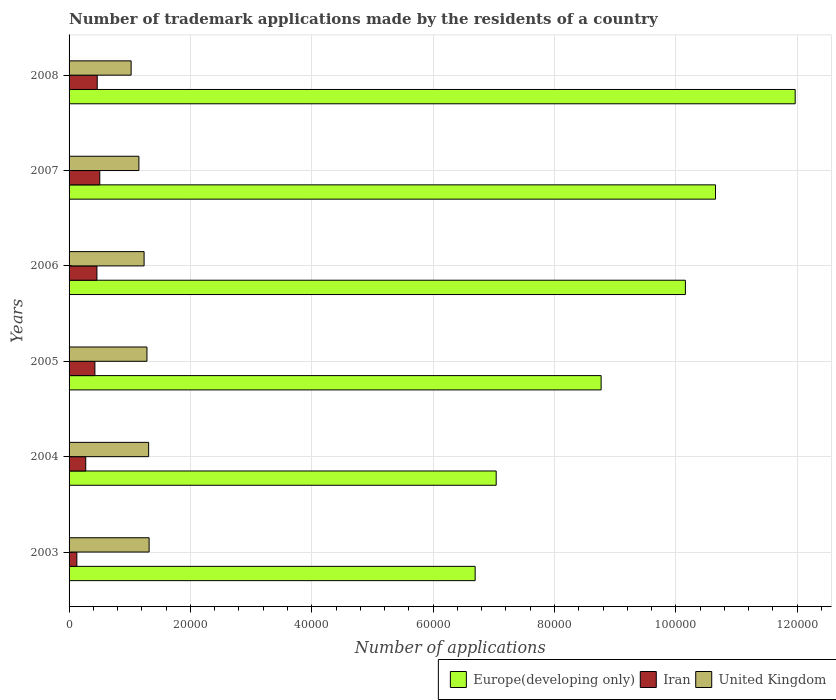How many different coloured bars are there?
Keep it short and to the point. 3. Are the number of bars per tick equal to the number of legend labels?
Provide a succinct answer. Yes. Are the number of bars on each tick of the Y-axis equal?
Your answer should be very brief. Yes. What is the label of the 4th group of bars from the top?
Keep it short and to the point. 2005. In how many cases, is the number of bars for a given year not equal to the number of legend labels?
Offer a terse response. 0. What is the number of trademark applications made by the residents in Iran in 2003?
Your answer should be very brief. 1280. Across all years, what is the maximum number of trademark applications made by the residents in Europe(developing only)?
Keep it short and to the point. 1.20e+05. Across all years, what is the minimum number of trademark applications made by the residents in Europe(developing only)?
Provide a short and direct response. 6.69e+04. In which year was the number of trademark applications made by the residents in United Kingdom maximum?
Make the answer very short. 2003. In which year was the number of trademark applications made by the residents in United Kingdom minimum?
Offer a terse response. 2008. What is the total number of trademark applications made by the residents in United Kingdom in the graph?
Your response must be concise. 7.32e+04. What is the difference between the number of trademark applications made by the residents in United Kingdom in 2004 and that in 2008?
Your answer should be very brief. 2885. What is the difference between the number of trademark applications made by the residents in Iran in 2008 and the number of trademark applications made by the residents in United Kingdom in 2007?
Provide a succinct answer. -6867. What is the average number of trademark applications made by the residents in Europe(developing only) per year?
Offer a terse response. 9.21e+04. In the year 2005, what is the difference between the number of trademark applications made by the residents in Iran and number of trademark applications made by the residents in Europe(developing only)?
Offer a very short reply. -8.34e+04. What is the ratio of the number of trademark applications made by the residents in Europe(developing only) in 2003 to that in 2008?
Make the answer very short. 0.56. Is the number of trademark applications made by the residents in Iran in 2003 less than that in 2005?
Offer a terse response. Yes. Is the difference between the number of trademark applications made by the residents in Iran in 2005 and 2007 greater than the difference between the number of trademark applications made by the residents in Europe(developing only) in 2005 and 2007?
Offer a terse response. Yes. What is the difference between the highest and the second highest number of trademark applications made by the residents in Iran?
Offer a terse response. 420. What is the difference between the highest and the lowest number of trademark applications made by the residents in Europe(developing only)?
Provide a succinct answer. 5.27e+04. Is the sum of the number of trademark applications made by the residents in Iran in 2003 and 2007 greater than the maximum number of trademark applications made by the residents in Europe(developing only) across all years?
Keep it short and to the point. No. What does the 1st bar from the top in 2007 represents?
Your answer should be very brief. United Kingdom. What does the 2nd bar from the bottom in 2007 represents?
Ensure brevity in your answer.  Iran. Is it the case that in every year, the sum of the number of trademark applications made by the residents in United Kingdom and number of trademark applications made by the residents in Europe(developing only) is greater than the number of trademark applications made by the residents in Iran?
Provide a succinct answer. Yes. How many bars are there?
Ensure brevity in your answer.  18. Are all the bars in the graph horizontal?
Provide a short and direct response. Yes. What is the difference between two consecutive major ticks on the X-axis?
Your answer should be very brief. 2.00e+04. Does the graph contain any zero values?
Provide a short and direct response. No. How many legend labels are there?
Offer a terse response. 3. What is the title of the graph?
Provide a short and direct response. Number of trademark applications made by the residents of a country. What is the label or title of the X-axis?
Make the answer very short. Number of applications. What is the Number of applications in Europe(developing only) in 2003?
Your answer should be very brief. 6.69e+04. What is the Number of applications in Iran in 2003?
Give a very brief answer. 1280. What is the Number of applications in United Kingdom in 2003?
Your response must be concise. 1.32e+04. What is the Number of applications of Europe(developing only) in 2004?
Offer a terse response. 7.04e+04. What is the Number of applications in Iran in 2004?
Provide a succinct answer. 2748. What is the Number of applications of United Kingdom in 2004?
Keep it short and to the point. 1.31e+04. What is the Number of applications of Europe(developing only) in 2005?
Ensure brevity in your answer.  8.77e+04. What is the Number of applications in Iran in 2005?
Ensure brevity in your answer.  4255. What is the Number of applications of United Kingdom in 2005?
Ensure brevity in your answer.  1.28e+04. What is the Number of applications of Europe(developing only) in 2006?
Keep it short and to the point. 1.02e+05. What is the Number of applications in Iran in 2006?
Give a very brief answer. 4591. What is the Number of applications of United Kingdom in 2006?
Your answer should be compact. 1.24e+04. What is the Number of applications in Europe(developing only) in 2007?
Ensure brevity in your answer.  1.07e+05. What is the Number of applications in Iran in 2007?
Your answer should be very brief. 5061. What is the Number of applications of United Kingdom in 2007?
Offer a terse response. 1.15e+04. What is the Number of applications in Europe(developing only) in 2008?
Your answer should be compact. 1.20e+05. What is the Number of applications of Iran in 2008?
Provide a succinct answer. 4641. What is the Number of applications in United Kingdom in 2008?
Make the answer very short. 1.02e+04. Across all years, what is the maximum Number of applications in Europe(developing only)?
Offer a very short reply. 1.20e+05. Across all years, what is the maximum Number of applications of Iran?
Your answer should be very brief. 5061. Across all years, what is the maximum Number of applications in United Kingdom?
Make the answer very short. 1.32e+04. Across all years, what is the minimum Number of applications of Europe(developing only)?
Offer a very short reply. 6.69e+04. Across all years, what is the minimum Number of applications in Iran?
Your answer should be compact. 1280. Across all years, what is the minimum Number of applications of United Kingdom?
Your response must be concise. 1.02e+04. What is the total Number of applications in Europe(developing only) in the graph?
Keep it short and to the point. 5.53e+05. What is the total Number of applications in Iran in the graph?
Provide a short and direct response. 2.26e+04. What is the total Number of applications of United Kingdom in the graph?
Provide a succinct answer. 7.32e+04. What is the difference between the Number of applications in Europe(developing only) in 2003 and that in 2004?
Give a very brief answer. -3467. What is the difference between the Number of applications in Iran in 2003 and that in 2004?
Your response must be concise. -1468. What is the difference between the Number of applications in United Kingdom in 2003 and that in 2004?
Your answer should be very brief. 78. What is the difference between the Number of applications in Europe(developing only) in 2003 and that in 2005?
Offer a very short reply. -2.08e+04. What is the difference between the Number of applications in Iran in 2003 and that in 2005?
Offer a terse response. -2975. What is the difference between the Number of applications in United Kingdom in 2003 and that in 2005?
Provide a short and direct response. 356. What is the difference between the Number of applications of Europe(developing only) in 2003 and that in 2006?
Your answer should be very brief. -3.46e+04. What is the difference between the Number of applications of Iran in 2003 and that in 2006?
Offer a very short reply. -3311. What is the difference between the Number of applications of United Kingdom in 2003 and that in 2006?
Your response must be concise. 826. What is the difference between the Number of applications in Europe(developing only) in 2003 and that in 2007?
Give a very brief answer. -3.96e+04. What is the difference between the Number of applications of Iran in 2003 and that in 2007?
Your response must be concise. -3781. What is the difference between the Number of applications in United Kingdom in 2003 and that in 2007?
Make the answer very short. 1683. What is the difference between the Number of applications in Europe(developing only) in 2003 and that in 2008?
Give a very brief answer. -5.27e+04. What is the difference between the Number of applications in Iran in 2003 and that in 2008?
Your answer should be compact. -3361. What is the difference between the Number of applications of United Kingdom in 2003 and that in 2008?
Provide a short and direct response. 2963. What is the difference between the Number of applications of Europe(developing only) in 2004 and that in 2005?
Offer a very short reply. -1.73e+04. What is the difference between the Number of applications in Iran in 2004 and that in 2005?
Provide a short and direct response. -1507. What is the difference between the Number of applications of United Kingdom in 2004 and that in 2005?
Ensure brevity in your answer.  278. What is the difference between the Number of applications of Europe(developing only) in 2004 and that in 2006?
Your answer should be very brief. -3.12e+04. What is the difference between the Number of applications in Iran in 2004 and that in 2006?
Keep it short and to the point. -1843. What is the difference between the Number of applications in United Kingdom in 2004 and that in 2006?
Provide a short and direct response. 748. What is the difference between the Number of applications in Europe(developing only) in 2004 and that in 2007?
Make the answer very short. -3.61e+04. What is the difference between the Number of applications of Iran in 2004 and that in 2007?
Offer a terse response. -2313. What is the difference between the Number of applications of United Kingdom in 2004 and that in 2007?
Your answer should be very brief. 1605. What is the difference between the Number of applications in Europe(developing only) in 2004 and that in 2008?
Make the answer very short. -4.93e+04. What is the difference between the Number of applications of Iran in 2004 and that in 2008?
Provide a succinct answer. -1893. What is the difference between the Number of applications in United Kingdom in 2004 and that in 2008?
Give a very brief answer. 2885. What is the difference between the Number of applications of Europe(developing only) in 2005 and that in 2006?
Keep it short and to the point. -1.39e+04. What is the difference between the Number of applications in Iran in 2005 and that in 2006?
Give a very brief answer. -336. What is the difference between the Number of applications in United Kingdom in 2005 and that in 2006?
Your response must be concise. 470. What is the difference between the Number of applications in Europe(developing only) in 2005 and that in 2007?
Offer a terse response. -1.89e+04. What is the difference between the Number of applications of Iran in 2005 and that in 2007?
Ensure brevity in your answer.  -806. What is the difference between the Number of applications in United Kingdom in 2005 and that in 2007?
Your response must be concise. 1327. What is the difference between the Number of applications in Europe(developing only) in 2005 and that in 2008?
Make the answer very short. -3.20e+04. What is the difference between the Number of applications in Iran in 2005 and that in 2008?
Provide a succinct answer. -386. What is the difference between the Number of applications of United Kingdom in 2005 and that in 2008?
Provide a short and direct response. 2607. What is the difference between the Number of applications of Europe(developing only) in 2006 and that in 2007?
Make the answer very short. -4964. What is the difference between the Number of applications of Iran in 2006 and that in 2007?
Give a very brief answer. -470. What is the difference between the Number of applications of United Kingdom in 2006 and that in 2007?
Provide a short and direct response. 857. What is the difference between the Number of applications in Europe(developing only) in 2006 and that in 2008?
Provide a succinct answer. -1.81e+04. What is the difference between the Number of applications in Iran in 2006 and that in 2008?
Provide a succinct answer. -50. What is the difference between the Number of applications in United Kingdom in 2006 and that in 2008?
Provide a short and direct response. 2137. What is the difference between the Number of applications of Europe(developing only) in 2007 and that in 2008?
Make the answer very short. -1.31e+04. What is the difference between the Number of applications in Iran in 2007 and that in 2008?
Keep it short and to the point. 420. What is the difference between the Number of applications in United Kingdom in 2007 and that in 2008?
Your answer should be very brief. 1280. What is the difference between the Number of applications of Europe(developing only) in 2003 and the Number of applications of Iran in 2004?
Provide a short and direct response. 6.42e+04. What is the difference between the Number of applications of Europe(developing only) in 2003 and the Number of applications of United Kingdom in 2004?
Offer a terse response. 5.38e+04. What is the difference between the Number of applications of Iran in 2003 and the Number of applications of United Kingdom in 2004?
Offer a terse response. -1.18e+04. What is the difference between the Number of applications in Europe(developing only) in 2003 and the Number of applications in Iran in 2005?
Keep it short and to the point. 6.27e+04. What is the difference between the Number of applications of Europe(developing only) in 2003 and the Number of applications of United Kingdom in 2005?
Ensure brevity in your answer.  5.41e+04. What is the difference between the Number of applications of Iran in 2003 and the Number of applications of United Kingdom in 2005?
Offer a very short reply. -1.16e+04. What is the difference between the Number of applications in Europe(developing only) in 2003 and the Number of applications in Iran in 2006?
Your response must be concise. 6.23e+04. What is the difference between the Number of applications of Europe(developing only) in 2003 and the Number of applications of United Kingdom in 2006?
Keep it short and to the point. 5.46e+04. What is the difference between the Number of applications of Iran in 2003 and the Number of applications of United Kingdom in 2006?
Your answer should be compact. -1.11e+04. What is the difference between the Number of applications of Europe(developing only) in 2003 and the Number of applications of Iran in 2007?
Keep it short and to the point. 6.19e+04. What is the difference between the Number of applications in Europe(developing only) in 2003 and the Number of applications in United Kingdom in 2007?
Provide a short and direct response. 5.54e+04. What is the difference between the Number of applications of Iran in 2003 and the Number of applications of United Kingdom in 2007?
Give a very brief answer. -1.02e+04. What is the difference between the Number of applications of Europe(developing only) in 2003 and the Number of applications of Iran in 2008?
Your response must be concise. 6.23e+04. What is the difference between the Number of applications of Europe(developing only) in 2003 and the Number of applications of United Kingdom in 2008?
Keep it short and to the point. 5.67e+04. What is the difference between the Number of applications in Iran in 2003 and the Number of applications in United Kingdom in 2008?
Keep it short and to the point. -8948. What is the difference between the Number of applications in Europe(developing only) in 2004 and the Number of applications in Iran in 2005?
Offer a terse response. 6.61e+04. What is the difference between the Number of applications of Europe(developing only) in 2004 and the Number of applications of United Kingdom in 2005?
Your answer should be compact. 5.76e+04. What is the difference between the Number of applications of Iran in 2004 and the Number of applications of United Kingdom in 2005?
Make the answer very short. -1.01e+04. What is the difference between the Number of applications in Europe(developing only) in 2004 and the Number of applications in Iran in 2006?
Offer a very short reply. 6.58e+04. What is the difference between the Number of applications of Europe(developing only) in 2004 and the Number of applications of United Kingdom in 2006?
Your answer should be very brief. 5.80e+04. What is the difference between the Number of applications of Iran in 2004 and the Number of applications of United Kingdom in 2006?
Your response must be concise. -9617. What is the difference between the Number of applications in Europe(developing only) in 2004 and the Number of applications in Iran in 2007?
Ensure brevity in your answer.  6.53e+04. What is the difference between the Number of applications of Europe(developing only) in 2004 and the Number of applications of United Kingdom in 2007?
Offer a very short reply. 5.89e+04. What is the difference between the Number of applications in Iran in 2004 and the Number of applications in United Kingdom in 2007?
Give a very brief answer. -8760. What is the difference between the Number of applications of Europe(developing only) in 2004 and the Number of applications of Iran in 2008?
Your answer should be compact. 6.58e+04. What is the difference between the Number of applications of Europe(developing only) in 2004 and the Number of applications of United Kingdom in 2008?
Ensure brevity in your answer.  6.02e+04. What is the difference between the Number of applications of Iran in 2004 and the Number of applications of United Kingdom in 2008?
Give a very brief answer. -7480. What is the difference between the Number of applications in Europe(developing only) in 2005 and the Number of applications in Iran in 2006?
Offer a terse response. 8.31e+04. What is the difference between the Number of applications in Europe(developing only) in 2005 and the Number of applications in United Kingdom in 2006?
Keep it short and to the point. 7.53e+04. What is the difference between the Number of applications in Iran in 2005 and the Number of applications in United Kingdom in 2006?
Ensure brevity in your answer.  -8110. What is the difference between the Number of applications of Europe(developing only) in 2005 and the Number of applications of Iran in 2007?
Provide a succinct answer. 8.26e+04. What is the difference between the Number of applications of Europe(developing only) in 2005 and the Number of applications of United Kingdom in 2007?
Offer a terse response. 7.62e+04. What is the difference between the Number of applications of Iran in 2005 and the Number of applications of United Kingdom in 2007?
Your response must be concise. -7253. What is the difference between the Number of applications of Europe(developing only) in 2005 and the Number of applications of Iran in 2008?
Your answer should be compact. 8.30e+04. What is the difference between the Number of applications in Europe(developing only) in 2005 and the Number of applications in United Kingdom in 2008?
Give a very brief answer. 7.75e+04. What is the difference between the Number of applications in Iran in 2005 and the Number of applications in United Kingdom in 2008?
Provide a succinct answer. -5973. What is the difference between the Number of applications of Europe(developing only) in 2006 and the Number of applications of Iran in 2007?
Provide a short and direct response. 9.65e+04. What is the difference between the Number of applications of Europe(developing only) in 2006 and the Number of applications of United Kingdom in 2007?
Offer a terse response. 9.01e+04. What is the difference between the Number of applications of Iran in 2006 and the Number of applications of United Kingdom in 2007?
Give a very brief answer. -6917. What is the difference between the Number of applications of Europe(developing only) in 2006 and the Number of applications of Iran in 2008?
Provide a succinct answer. 9.69e+04. What is the difference between the Number of applications of Europe(developing only) in 2006 and the Number of applications of United Kingdom in 2008?
Ensure brevity in your answer.  9.13e+04. What is the difference between the Number of applications in Iran in 2006 and the Number of applications in United Kingdom in 2008?
Your answer should be compact. -5637. What is the difference between the Number of applications in Europe(developing only) in 2007 and the Number of applications in Iran in 2008?
Ensure brevity in your answer.  1.02e+05. What is the difference between the Number of applications in Europe(developing only) in 2007 and the Number of applications in United Kingdom in 2008?
Your answer should be compact. 9.63e+04. What is the difference between the Number of applications of Iran in 2007 and the Number of applications of United Kingdom in 2008?
Provide a short and direct response. -5167. What is the average Number of applications of Europe(developing only) per year?
Your answer should be compact. 9.21e+04. What is the average Number of applications of Iran per year?
Your response must be concise. 3762.67. What is the average Number of applications in United Kingdom per year?
Your answer should be compact. 1.22e+04. In the year 2003, what is the difference between the Number of applications of Europe(developing only) and Number of applications of Iran?
Keep it short and to the point. 6.56e+04. In the year 2003, what is the difference between the Number of applications of Europe(developing only) and Number of applications of United Kingdom?
Ensure brevity in your answer.  5.37e+04. In the year 2003, what is the difference between the Number of applications of Iran and Number of applications of United Kingdom?
Keep it short and to the point. -1.19e+04. In the year 2004, what is the difference between the Number of applications of Europe(developing only) and Number of applications of Iran?
Your answer should be compact. 6.76e+04. In the year 2004, what is the difference between the Number of applications of Europe(developing only) and Number of applications of United Kingdom?
Provide a succinct answer. 5.73e+04. In the year 2004, what is the difference between the Number of applications in Iran and Number of applications in United Kingdom?
Offer a terse response. -1.04e+04. In the year 2005, what is the difference between the Number of applications in Europe(developing only) and Number of applications in Iran?
Provide a short and direct response. 8.34e+04. In the year 2005, what is the difference between the Number of applications in Europe(developing only) and Number of applications in United Kingdom?
Keep it short and to the point. 7.48e+04. In the year 2005, what is the difference between the Number of applications of Iran and Number of applications of United Kingdom?
Give a very brief answer. -8580. In the year 2006, what is the difference between the Number of applications in Europe(developing only) and Number of applications in Iran?
Keep it short and to the point. 9.70e+04. In the year 2006, what is the difference between the Number of applications of Europe(developing only) and Number of applications of United Kingdom?
Provide a short and direct response. 8.92e+04. In the year 2006, what is the difference between the Number of applications of Iran and Number of applications of United Kingdom?
Provide a succinct answer. -7774. In the year 2007, what is the difference between the Number of applications in Europe(developing only) and Number of applications in Iran?
Offer a terse response. 1.01e+05. In the year 2007, what is the difference between the Number of applications in Europe(developing only) and Number of applications in United Kingdom?
Offer a terse response. 9.50e+04. In the year 2007, what is the difference between the Number of applications in Iran and Number of applications in United Kingdom?
Keep it short and to the point. -6447. In the year 2008, what is the difference between the Number of applications of Europe(developing only) and Number of applications of Iran?
Give a very brief answer. 1.15e+05. In the year 2008, what is the difference between the Number of applications in Europe(developing only) and Number of applications in United Kingdom?
Your answer should be compact. 1.09e+05. In the year 2008, what is the difference between the Number of applications of Iran and Number of applications of United Kingdom?
Offer a terse response. -5587. What is the ratio of the Number of applications of Europe(developing only) in 2003 to that in 2004?
Offer a terse response. 0.95. What is the ratio of the Number of applications in Iran in 2003 to that in 2004?
Offer a very short reply. 0.47. What is the ratio of the Number of applications of United Kingdom in 2003 to that in 2004?
Provide a short and direct response. 1.01. What is the ratio of the Number of applications of Europe(developing only) in 2003 to that in 2005?
Your response must be concise. 0.76. What is the ratio of the Number of applications of Iran in 2003 to that in 2005?
Give a very brief answer. 0.3. What is the ratio of the Number of applications in United Kingdom in 2003 to that in 2005?
Keep it short and to the point. 1.03. What is the ratio of the Number of applications of Europe(developing only) in 2003 to that in 2006?
Your answer should be very brief. 0.66. What is the ratio of the Number of applications in Iran in 2003 to that in 2006?
Offer a terse response. 0.28. What is the ratio of the Number of applications of United Kingdom in 2003 to that in 2006?
Make the answer very short. 1.07. What is the ratio of the Number of applications in Europe(developing only) in 2003 to that in 2007?
Ensure brevity in your answer.  0.63. What is the ratio of the Number of applications in Iran in 2003 to that in 2007?
Your answer should be compact. 0.25. What is the ratio of the Number of applications in United Kingdom in 2003 to that in 2007?
Keep it short and to the point. 1.15. What is the ratio of the Number of applications in Europe(developing only) in 2003 to that in 2008?
Offer a terse response. 0.56. What is the ratio of the Number of applications of Iran in 2003 to that in 2008?
Offer a terse response. 0.28. What is the ratio of the Number of applications of United Kingdom in 2003 to that in 2008?
Your answer should be very brief. 1.29. What is the ratio of the Number of applications of Europe(developing only) in 2004 to that in 2005?
Your answer should be compact. 0.8. What is the ratio of the Number of applications in Iran in 2004 to that in 2005?
Offer a terse response. 0.65. What is the ratio of the Number of applications in United Kingdom in 2004 to that in 2005?
Keep it short and to the point. 1.02. What is the ratio of the Number of applications in Europe(developing only) in 2004 to that in 2006?
Make the answer very short. 0.69. What is the ratio of the Number of applications of Iran in 2004 to that in 2006?
Offer a terse response. 0.6. What is the ratio of the Number of applications in United Kingdom in 2004 to that in 2006?
Your response must be concise. 1.06. What is the ratio of the Number of applications in Europe(developing only) in 2004 to that in 2007?
Your answer should be compact. 0.66. What is the ratio of the Number of applications in Iran in 2004 to that in 2007?
Make the answer very short. 0.54. What is the ratio of the Number of applications in United Kingdom in 2004 to that in 2007?
Provide a short and direct response. 1.14. What is the ratio of the Number of applications of Europe(developing only) in 2004 to that in 2008?
Keep it short and to the point. 0.59. What is the ratio of the Number of applications of Iran in 2004 to that in 2008?
Offer a terse response. 0.59. What is the ratio of the Number of applications of United Kingdom in 2004 to that in 2008?
Provide a short and direct response. 1.28. What is the ratio of the Number of applications in Europe(developing only) in 2005 to that in 2006?
Keep it short and to the point. 0.86. What is the ratio of the Number of applications of Iran in 2005 to that in 2006?
Offer a terse response. 0.93. What is the ratio of the Number of applications in United Kingdom in 2005 to that in 2006?
Provide a short and direct response. 1.04. What is the ratio of the Number of applications in Europe(developing only) in 2005 to that in 2007?
Keep it short and to the point. 0.82. What is the ratio of the Number of applications in Iran in 2005 to that in 2007?
Provide a short and direct response. 0.84. What is the ratio of the Number of applications of United Kingdom in 2005 to that in 2007?
Offer a terse response. 1.12. What is the ratio of the Number of applications in Europe(developing only) in 2005 to that in 2008?
Your answer should be compact. 0.73. What is the ratio of the Number of applications in Iran in 2005 to that in 2008?
Provide a short and direct response. 0.92. What is the ratio of the Number of applications in United Kingdom in 2005 to that in 2008?
Offer a terse response. 1.25. What is the ratio of the Number of applications in Europe(developing only) in 2006 to that in 2007?
Your answer should be very brief. 0.95. What is the ratio of the Number of applications of Iran in 2006 to that in 2007?
Offer a terse response. 0.91. What is the ratio of the Number of applications of United Kingdom in 2006 to that in 2007?
Offer a terse response. 1.07. What is the ratio of the Number of applications of Europe(developing only) in 2006 to that in 2008?
Your answer should be very brief. 0.85. What is the ratio of the Number of applications in United Kingdom in 2006 to that in 2008?
Your answer should be compact. 1.21. What is the ratio of the Number of applications in Europe(developing only) in 2007 to that in 2008?
Make the answer very short. 0.89. What is the ratio of the Number of applications of Iran in 2007 to that in 2008?
Your answer should be compact. 1.09. What is the ratio of the Number of applications in United Kingdom in 2007 to that in 2008?
Offer a terse response. 1.13. What is the difference between the highest and the second highest Number of applications in Europe(developing only)?
Keep it short and to the point. 1.31e+04. What is the difference between the highest and the second highest Number of applications in Iran?
Make the answer very short. 420. What is the difference between the highest and the second highest Number of applications in United Kingdom?
Ensure brevity in your answer.  78. What is the difference between the highest and the lowest Number of applications in Europe(developing only)?
Provide a short and direct response. 5.27e+04. What is the difference between the highest and the lowest Number of applications in Iran?
Offer a very short reply. 3781. What is the difference between the highest and the lowest Number of applications in United Kingdom?
Ensure brevity in your answer.  2963. 